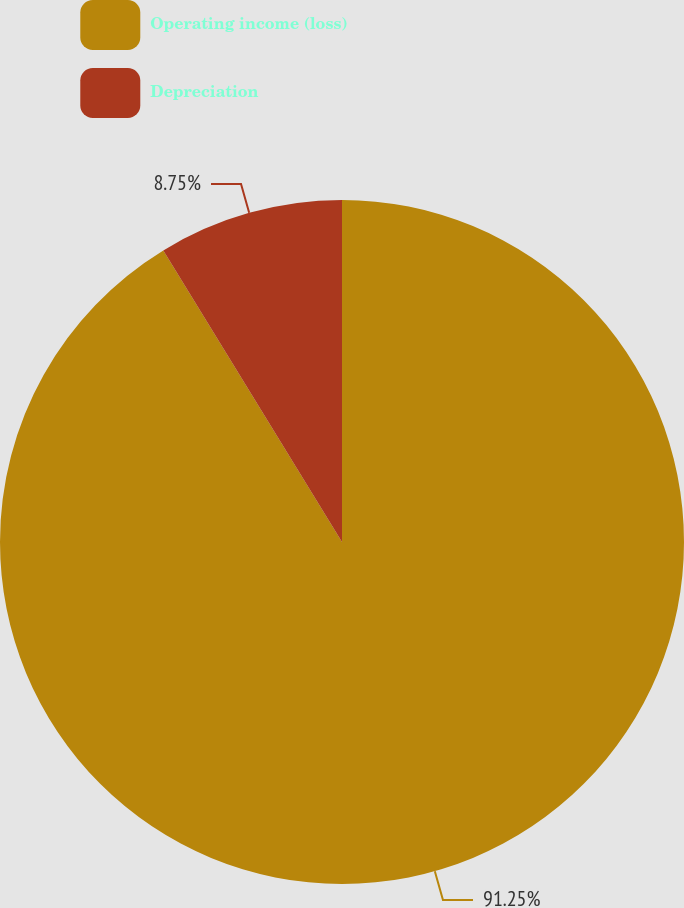<chart> <loc_0><loc_0><loc_500><loc_500><pie_chart><fcel>Operating income (loss)<fcel>Depreciation<nl><fcel>91.25%<fcel>8.75%<nl></chart> 